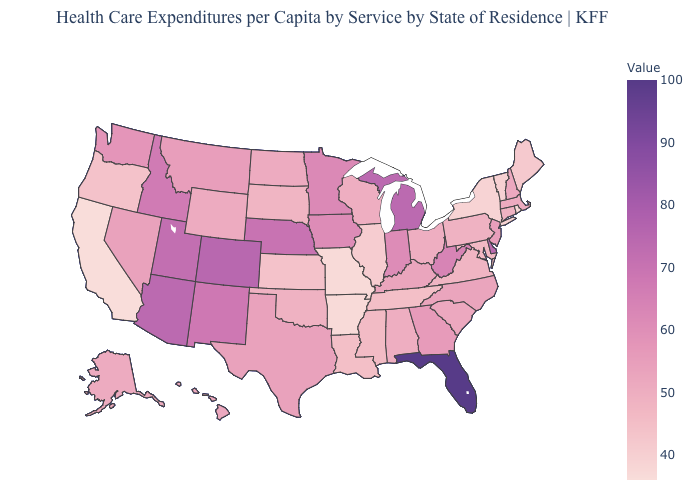Which states hav the highest value in the South?
Be succinct. Florida. Does the map have missing data?
Concise answer only. No. Which states have the lowest value in the USA?
Answer briefly. California. Does Tennessee have the lowest value in the USA?
Short answer required. No. Does Nebraska have the lowest value in the USA?
Write a very short answer. No. Does Minnesota have a lower value than Colorado?
Keep it brief. Yes. Which states have the lowest value in the USA?
Give a very brief answer. California. 